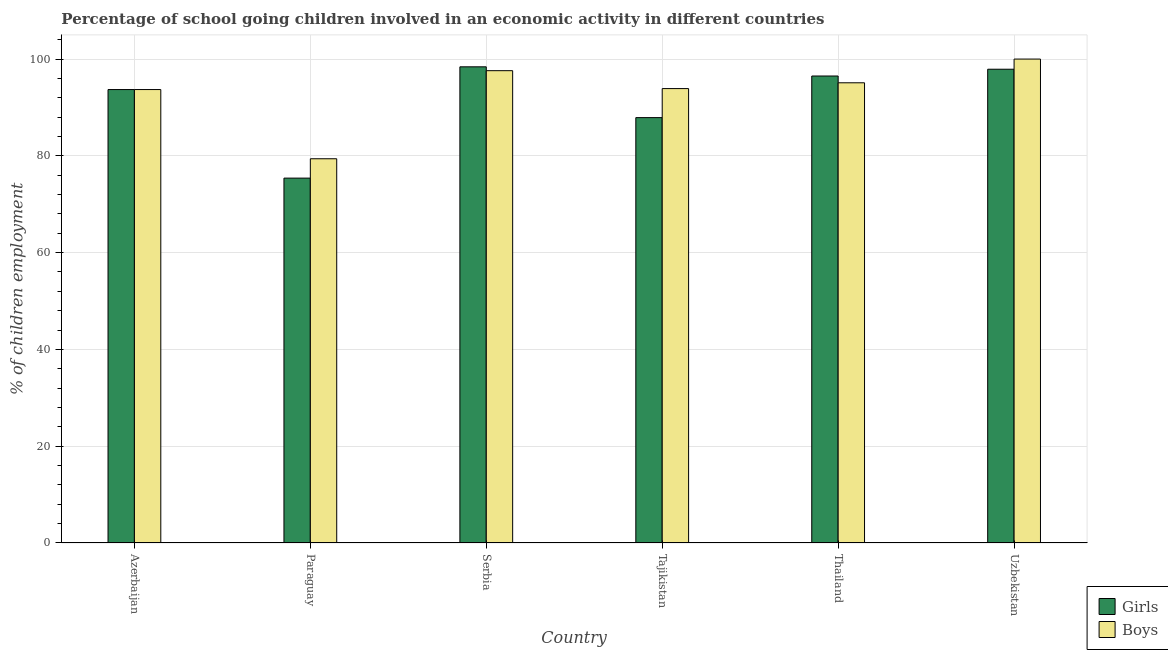How many different coloured bars are there?
Ensure brevity in your answer.  2. How many groups of bars are there?
Make the answer very short. 6. Are the number of bars on each tick of the X-axis equal?
Offer a terse response. Yes. How many bars are there on the 1st tick from the left?
Your response must be concise. 2. How many bars are there on the 2nd tick from the right?
Your response must be concise. 2. What is the label of the 2nd group of bars from the left?
Provide a short and direct response. Paraguay. What is the percentage of school going boys in Paraguay?
Provide a succinct answer. 79.4. Across all countries, what is the maximum percentage of school going girls?
Give a very brief answer. 98.4. Across all countries, what is the minimum percentage of school going boys?
Ensure brevity in your answer.  79.4. In which country was the percentage of school going boys maximum?
Keep it short and to the point. Uzbekistan. In which country was the percentage of school going boys minimum?
Provide a short and direct response. Paraguay. What is the total percentage of school going boys in the graph?
Offer a terse response. 559.7. What is the difference between the percentage of school going boys in Serbia and that in Tajikistan?
Make the answer very short. 3.7. What is the difference between the percentage of school going girls in Azerbaijan and the percentage of school going boys in Uzbekistan?
Ensure brevity in your answer.  -6.3. What is the average percentage of school going girls per country?
Your response must be concise. 91.63. What is the difference between the percentage of school going girls and percentage of school going boys in Paraguay?
Make the answer very short. -4. In how many countries, is the percentage of school going boys greater than 64 %?
Ensure brevity in your answer.  6. What is the ratio of the percentage of school going girls in Serbia to that in Uzbekistan?
Ensure brevity in your answer.  1.01. Is the difference between the percentage of school going boys in Azerbaijan and Thailand greater than the difference between the percentage of school going girls in Azerbaijan and Thailand?
Ensure brevity in your answer.  Yes. What is the difference between the highest and the second highest percentage of school going boys?
Keep it short and to the point. 2.4. What is the difference between the highest and the lowest percentage of school going boys?
Offer a very short reply. 20.6. Is the sum of the percentage of school going boys in Azerbaijan and Uzbekistan greater than the maximum percentage of school going girls across all countries?
Ensure brevity in your answer.  Yes. What does the 1st bar from the left in Azerbaijan represents?
Give a very brief answer. Girls. What does the 2nd bar from the right in Azerbaijan represents?
Your answer should be compact. Girls. How many countries are there in the graph?
Your response must be concise. 6. Are the values on the major ticks of Y-axis written in scientific E-notation?
Provide a succinct answer. No. Does the graph contain any zero values?
Your answer should be compact. No. How many legend labels are there?
Provide a short and direct response. 2. What is the title of the graph?
Ensure brevity in your answer.  Percentage of school going children involved in an economic activity in different countries. What is the label or title of the Y-axis?
Make the answer very short. % of children employment. What is the % of children employment in Girls in Azerbaijan?
Your response must be concise. 93.7. What is the % of children employment of Boys in Azerbaijan?
Make the answer very short. 93.7. What is the % of children employment in Girls in Paraguay?
Offer a terse response. 75.4. What is the % of children employment of Boys in Paraguay?
Provide a succinct answer. 79.4. What is the % of children employment of Girls in Serbia?
Your answer should be very brief. 98.4. What is the % of children employment in Boys in Serbia?
Give a very brief answer. 97.6. What is the % of children employment of Girls in Tajikistan?
Provide a succinct answer. 87.9. What is the % of children employment of Boys in Tajikistan?
Keep it short and to the point. 93.9. What is the % of children employment of Girls in Thailand?
Offer a very short reply. 96.5. What is the % of children employment in Boys in Thailand?
Provide a succinct answer. 95.1. What is the % of children employment of Girls in Uzbekistan?
Keep it short and to the point. 97.9. What is the % of children employment in Boys in Uzbekistan?
Keep it short and to the point. 100. Across all countries, what is the maximum % of children employment in Girls?
Provide a short and direct response. 98.4. Across all countries, what is the maximum % of children employment of Boys?
Provide a succinct answer. 100. Across all countries, what is the minimum % of children employment of Girls?
Make the answer very short. 75.4. Across all countries, what is the minimum % of children employment of Boys?
Give a very brief answer. 79.4. What is the total % of children employment of Girls in the graph?
Offer a terse response. 549.8. What is the total % of children employment of Boys in the graph?
Your response must be concise. 559.7. What is the difference between the % of children employment in Girls in Azerbaijan and that in Paraguay?
Ensure brevity in your answer.  18.3. What is the difference between the % of children employment in Girls in Azerbaijan and that in Thailand?
Your response must be concise. -2.8. What is the difference between the % of children employment of Girls in Azerbaijan and that in Uzbekistan?
Offer a terse response. -4.2. What is the difference between the % of children employment in Boys in Paraguay and that in Serbia?
Offer a very short reply. -18.2. What is the difference between the % of children employment in Boys in Paraguay and that in Tajikistan?
Provide a succinct answer. -14.5. What is the difference between the % of children employment of Girls in Paraguay and that in Thailand?
Provide a short and direct response. -21.1. What is the difference between the % of children employment of Boys in Paraguay and that in Thailand?
Provide a short and direct response. -15.7. What is the difference between the % of children employment of Girls in Paraguay and that in Uzbekistan?
Give a very brief answer. -22.5. What is the difference between the % of children employment in Boys in Paraguay and that in Uzbekistan?
Offer a terse response. -20.6. What is the difference between the % of children employment of Boys in Serbia and that in Thailand?
Ensure brevity in your answer.  2.5. What is the difference between the % of children employment in Boys in Serbia and that in Uzbekistan?
Your response must be concise. -2.4. What is the difference between the % of children employment of Girls in Tajikistan and that in Thailand?
Ensure brevity in your answer.  -8.6. What is the difference between the % of children employment of Girls in Tajikistan and that in Uzbekistan?
Your answer should be compact. -10. What is the difference between the % of children employment of Girls in Thailand and that in Uzbekistan?
Provide a succinct answer. -1.4. What is the difference between the % of children employment of Boys in Thailand and that in Uzbekistan?
Offer a very short reply. -4.9. What is the difference between the % of children employment in Girls in Azerbaijan and the % of children employment in Boys in Paraguay?
Your answer should be compact. 14.3. What is the difference between the % of children employment in Girls in Azerbaijan and the % of children employment in Boys in Serbia?
Your response must be concise. -3.9. What is the difference between the % of children employment of Girls in Azerbaijan and the % of children employment of Boys in Tajikistan?
Give a very brief answer. -0.2. What is the difference between the % of children employment in Girls in Azerbaijan and the % of children employment in Boys in Uzbekistan?
Offer a very short reply. -6.3. What is the difference between the % of children employment of Girls in Paraguay and the % of children employment of Boys in Serbia?
Your answer should be very brief. -22.2. What is the difference between the % of children employment in Girls in Paraguay and the % of children employment in Boys in Tajikistan?
Make the answer very short. -18.5. What is the difference between the % of children employment of Girls in Paraguay and the % of children employment of Boys in Thailand?
Ensure brevity in your answer.  -19.7. What is the difference between the % of children employment of Girls in Paraguay and the % of children employment of Boys in Uzbekistan?
Offer a very short reply. -24.6. What is the difference between the % of children employment of Girls in Serbia and the % of children employment of Boys in Tajikistan?
Offer a very short reply. 4.5. What is the difference between the % of children employment in Girls in Tajikistan and the % of children employment in Boys in Thailand?
Provide a succinct answer. -7.2. What is the difference between the % of children employment in Girls in Thailand and the % of children employment in Boys in Uzbekistan?
Ensure brevity in your answer.  -3.5. What is the average % of children employment in Girls per country?
Offer a terse response. 91.63. What is the average % of children employment of Boys per country?
Your answer should be very brief. 93.28. What is the difference between the % of children employment of Girls and % of children employment of Boys in Paraguay?
Ensure brevity in your answer.  -4. What is the difference between the % of children employment of Girls and % of children employment of Boys in Serbia?
Your answer should be very brief. 0.8. What is the difference between the % of children employment in Girls and % of children employment in Boys in Thailand?
Keep it short and to the point. 1.4. What is the ratio of the % of children employment of Girls in Azerbaijan to that in Paraguay?
Offer a terse response. 1.24. What is the ratio of the % of children employment in Boys in Azerbaijan to that in Paraguay?
Your answer should be very brief. 1.18. What is the ratio of the % of children employment in Girls in Azerbaijan to that in Serbia?
Offer a very short reply. 0.95. What is the ratio of the % of children employment of Boys in Azerbaijan to that in Serbia?
Your answer should be compact. 0.96. What is the ratio of the % of children employment in Girls in Azerbaijan to that in Tajikistan?
Offer a terse response. 1.07. What is the ratio of the % of children employment in Girls in Azerbaijan to that in Uzbekistan?
Make the answer very short. 0.96. What is the ratio of the % of children employment of Boys in Azerbaijan to that in Uzbekistan?
Your response must be concise. 0.94. What is the ratio of the % of children employment of Girls in Paraguay to that in Serbia?
Provide a succinct answer. 0.77. What is the ratio of the % of children employment in Boys in Paraguay to that in Serbia?
Offer a terse response. 0.81. What is the ratio of the % of children employment of Girls in Paraguay to that in Tajikistan?
Make the answer very short. 0.86. What is the ratio of the % of children employment of Boys in Paraguay to that in Tajikistan?
Keep it short and to the point. 0.85. What is the ratio of the % of children employment in Girls in Paraguay to that in Thailand?
Offer a terse response. 0.78. What is the ratio of the % of children employment in Boys in Paraguay to that in Thailand?
Ensure brevity in your answer.  0.83. What is the ratio of the % of children employment of Girls in Paraguay to that in Uzbekistan?
Offer a terse response. 0.77. What is the ratio of the % of children employment of Boys in Paraguay to that in Uzbekistan?
Offer a very short reply. 0.79. What is the ratio of the % of children employment in Girls in Serbia to that in Tajikistan?
Keep it short and to the point. 1.12. What is the ratio of the % of children employment in Boys in Serbia to that in Tajikistan?
Keep it short and to the point. 1.04. What is the ratio of the % of children employment in Girls in Serbia to that in Thailand?
Your answer should be very brief. 1.02. What is the ratio of the % of children employment of Boys in Serbia to that in Thailand?
Your response must be concise. 1.03. What is the ratio of the % of children employment of Girls in Serbia to that in Uzbekistan?
Your response must be concise. 1.01. What is the ratio of the % of children employment of Girls in Tajikistan to that in Thailand?
Keep it short and to the point. 0.91. What is the ratio of the % of children employment in Boys in Tajikistan to that in Thailand?
Provide a succinct answer. 0.99. What is the ratio of the % of children employment of Girls in Tajikistan to that in Uzbekistan?
Your response must be concise. 0.9. What is the ratio of the % of children employment in Boys in Tajikistan to that in Uzbekistan?
Ensure brevity in your answer.  0.94. What is the ratio of the % of children employment of Girls in Thailand to that in Uzbekistan?
Keep it short and to the point. 0.99. What is the ratio of the % of children employment of Boys in Thailand to that in Uzbekistan?
Your response must be concise. 0.95. What is the difference between the highest and the second highest % of children employment in Boys?
Ensure brevity in your answer.  2.4. What is the difference between the highest and the lowest % of children employment in Girls?
Your answer should be very brief. 23. What is the difference between the highest and the lowest % of children employment of Boys?
Your response must be concise. 20.6. 